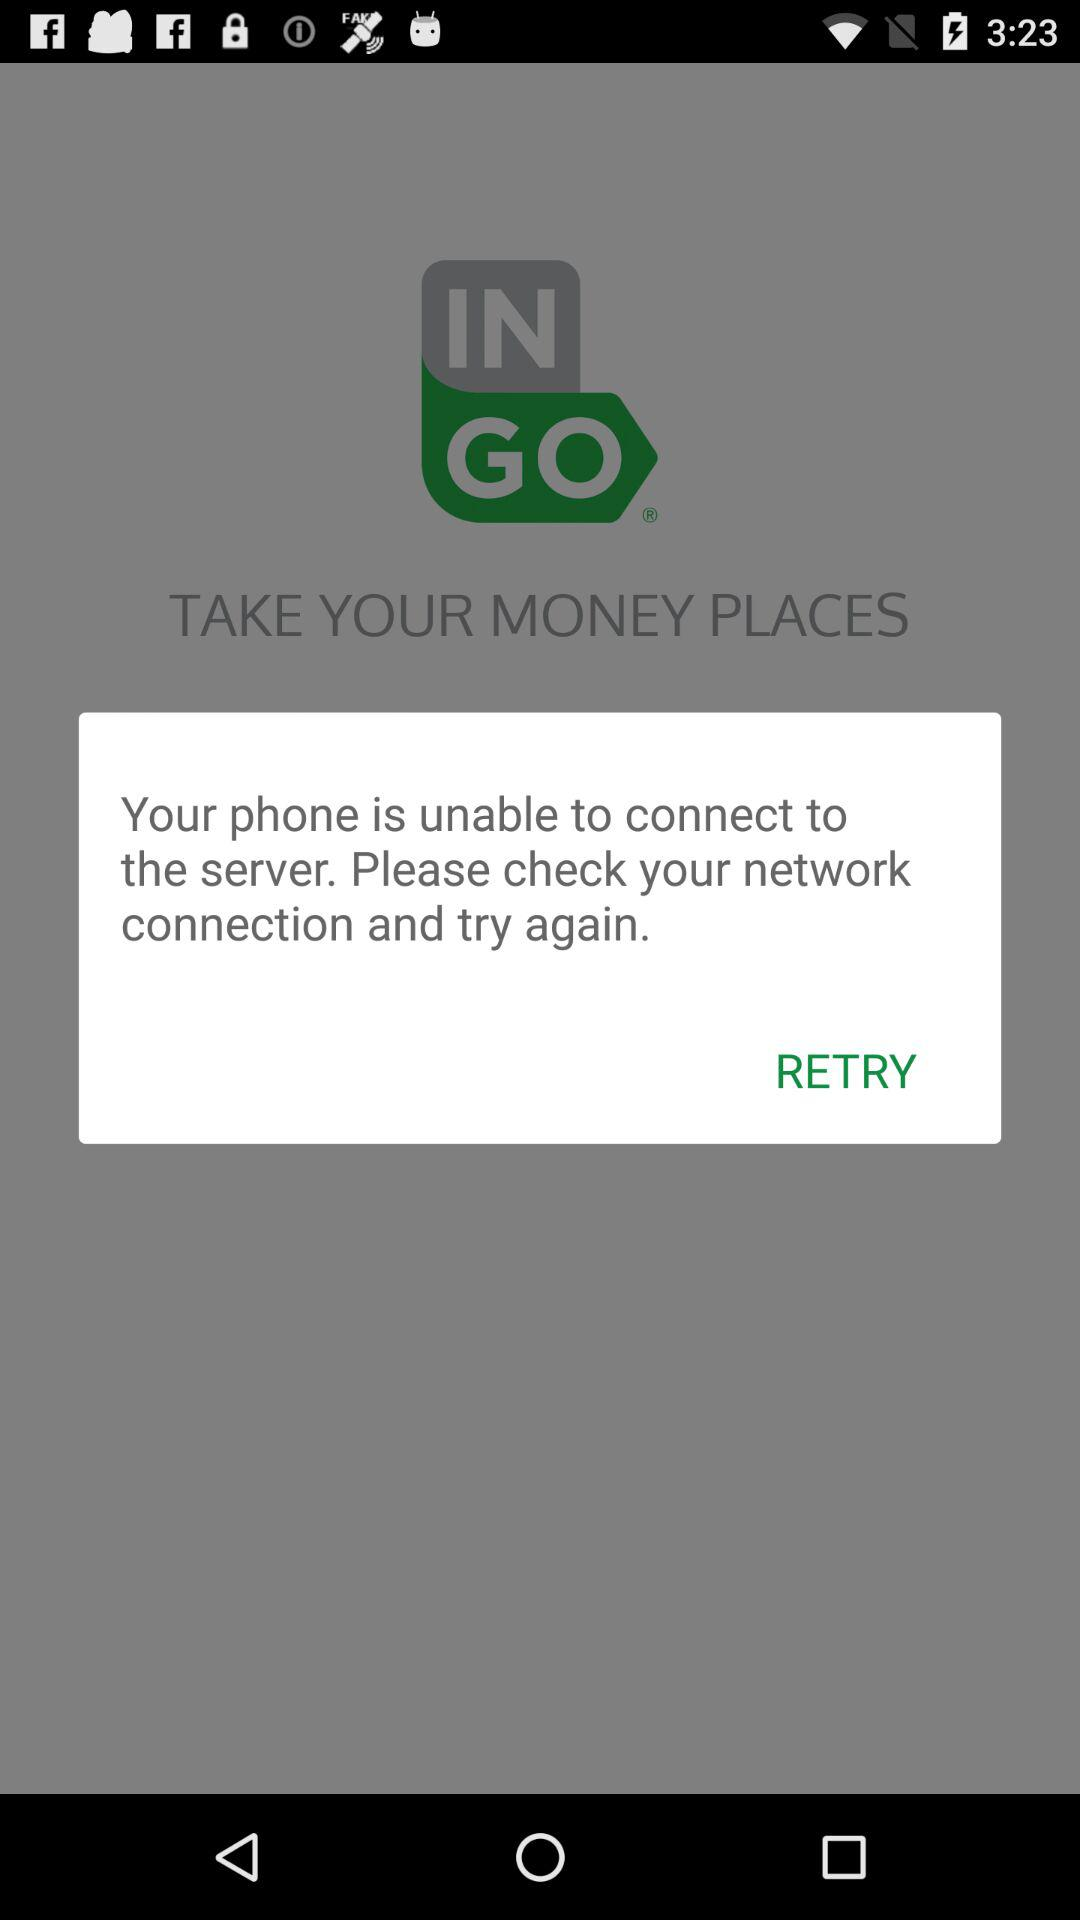What is the app name? The app name is "Ingo Money App – Cash Checks". 